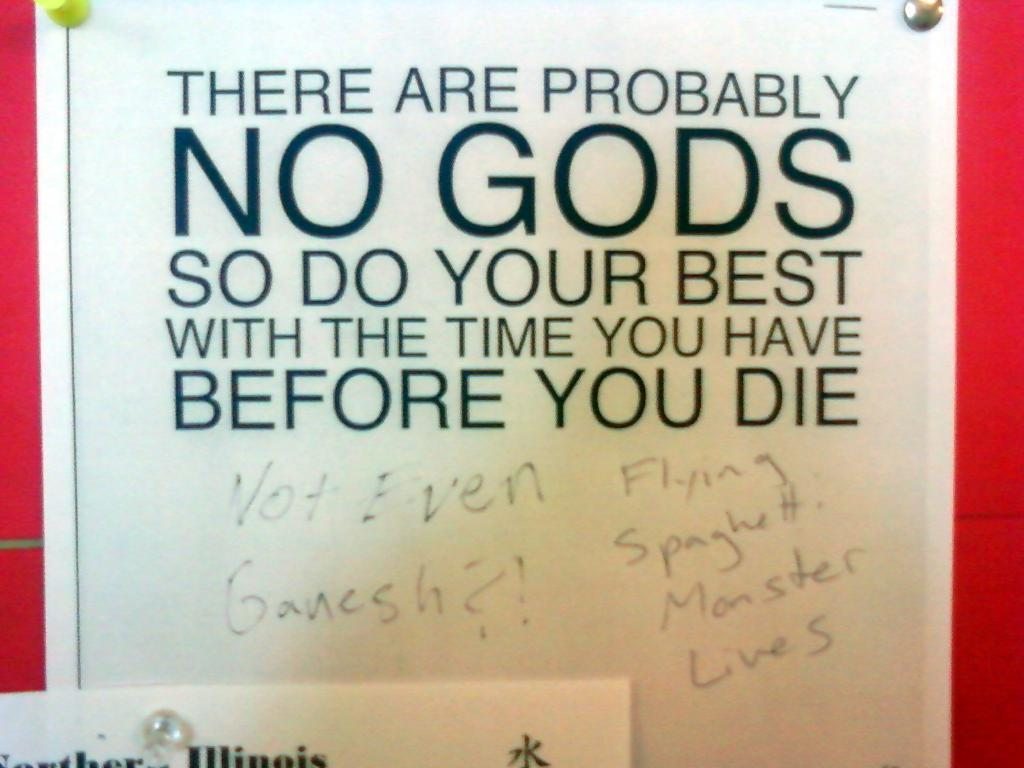<image>
Describe the image concisely. A bulletin sign that says there are probably no gods. 